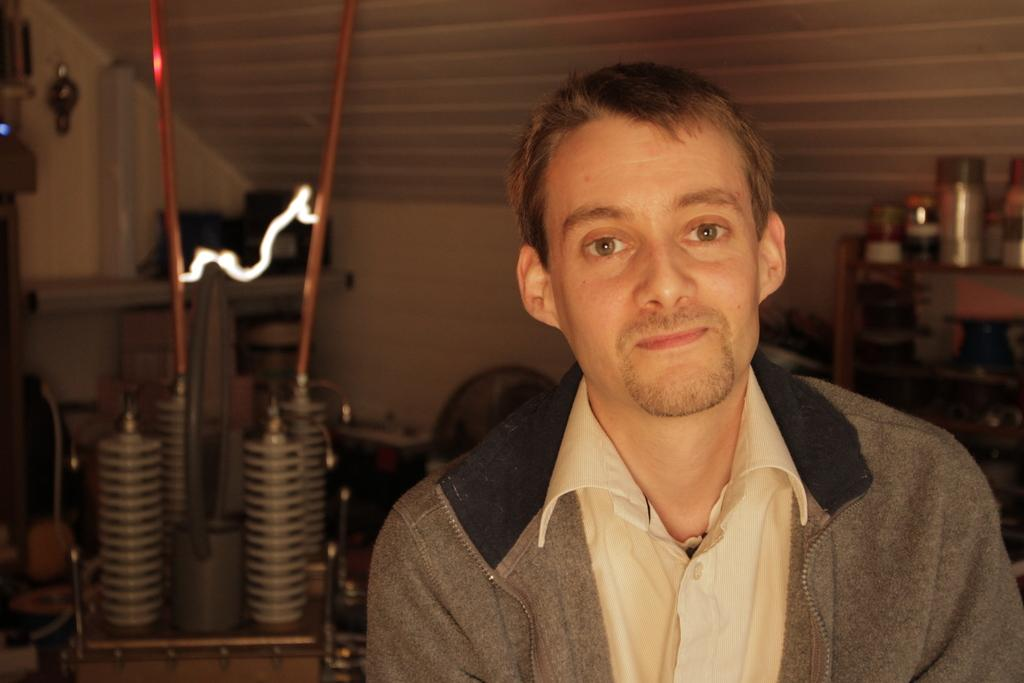What is the main subject in the foreground of the image? There is a person in the foreground of the image. What type of equipment can be seen on the left side of the image? There is electric equipment on the left side of the image. What architectural feature is visible in the background of the image? There is a roof visible in the background of the image. What common interest do the brothers share in the image? There is no mention of brothers or a common interest in the image. 